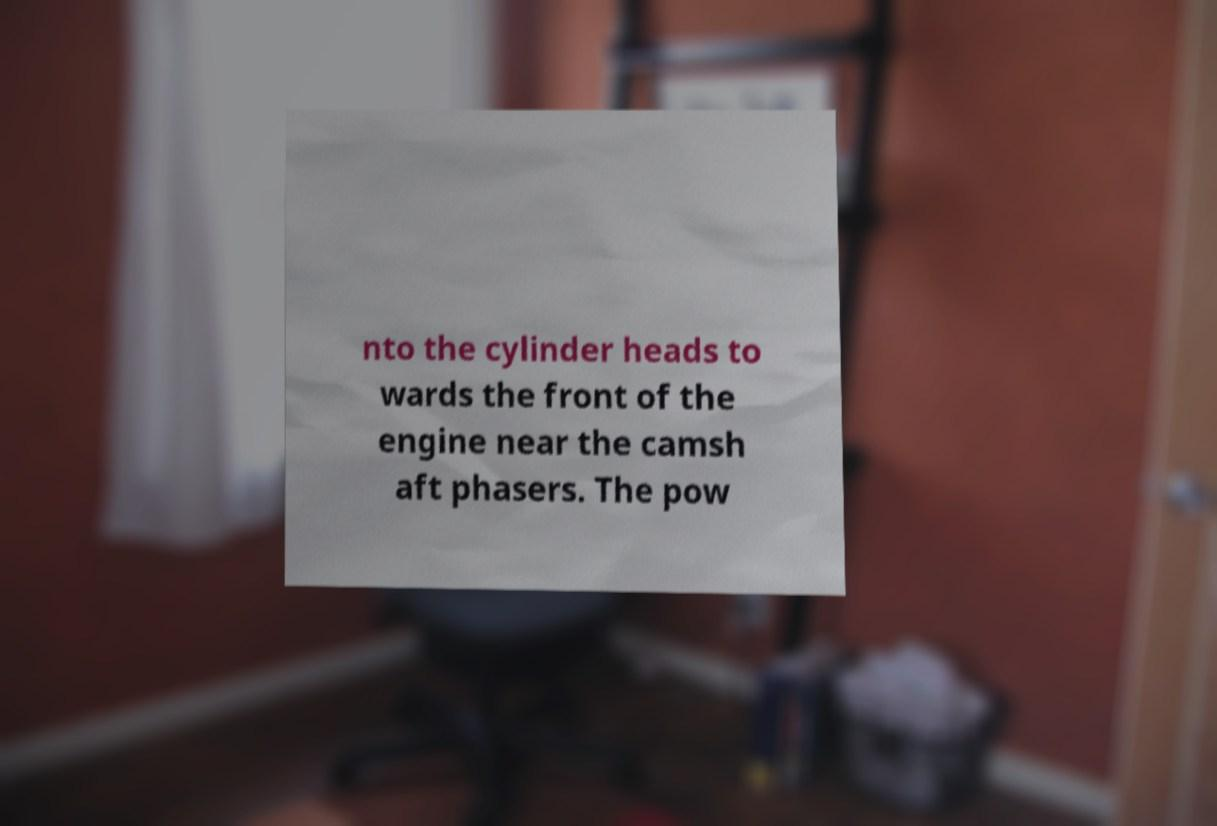Can you read and provide the text displayed in the image?This photo seems to have some interesting text. Can you extract and type it out for me? nto the cylinder heads to wards the front of the engine near the camsh aft phasers. The pow 